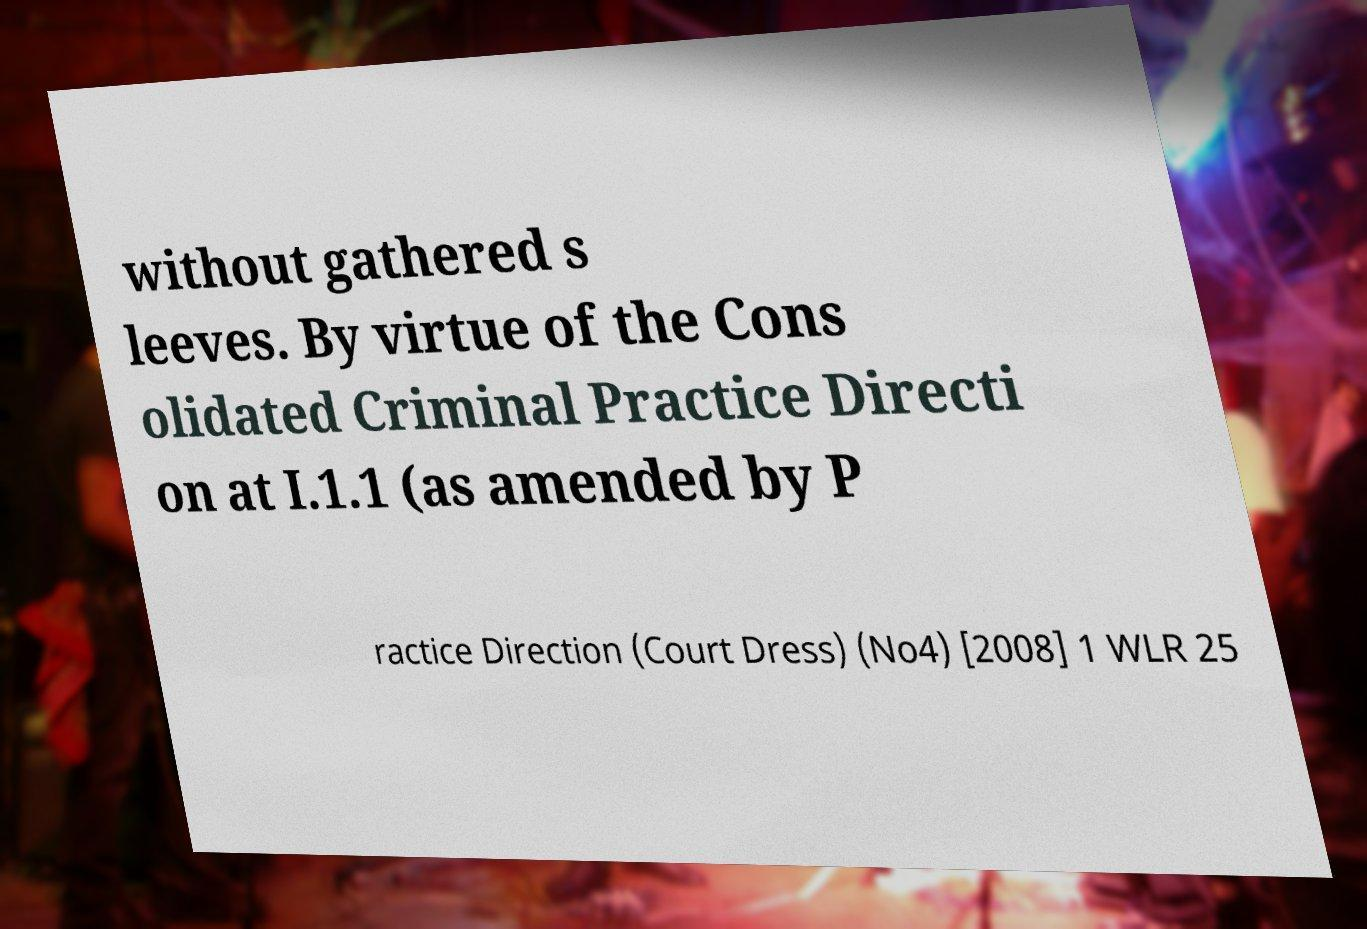There's text embedded in this image that I need extracted. Can you transcribe it verbatim? without gathered s leeves. By virtue of the Cons olidated Criminal Practice Directi on at I.1.1 (as amended by P ractice Direction (Court Dress) (No4) [2008] 1 WLR 25 